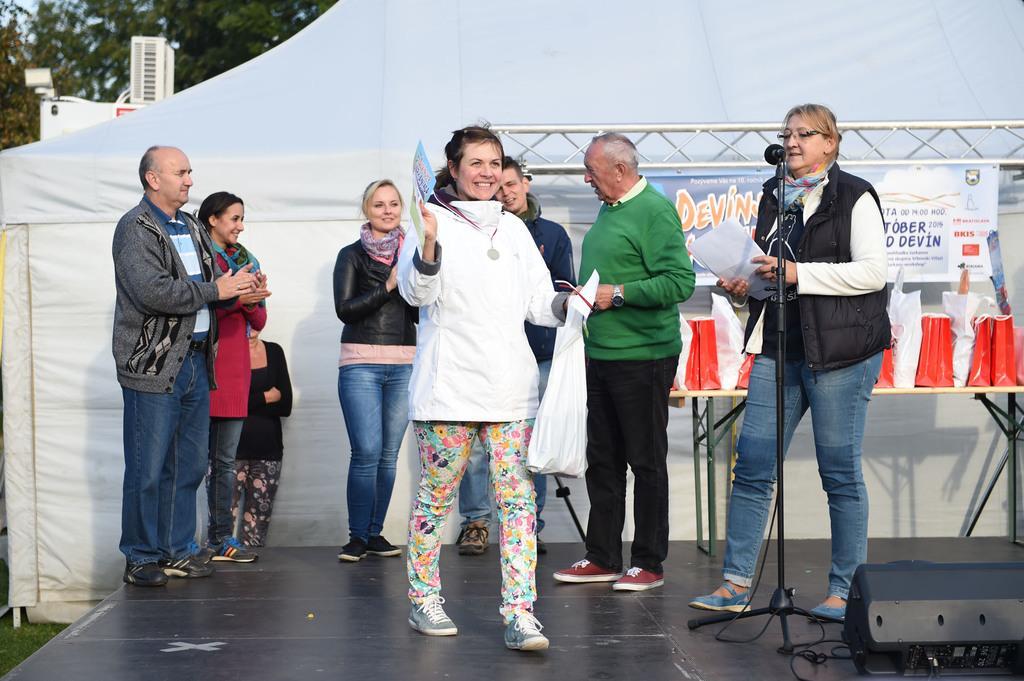How would you summarize this image in a sentence or two? In this image we can see men and women standing on the dais and some of them are holding polythene covers and papers in their hands, polythene covers on the table, iron grills, mic to the mic stand, cables, curtain, air conditioner, trees and sky. 